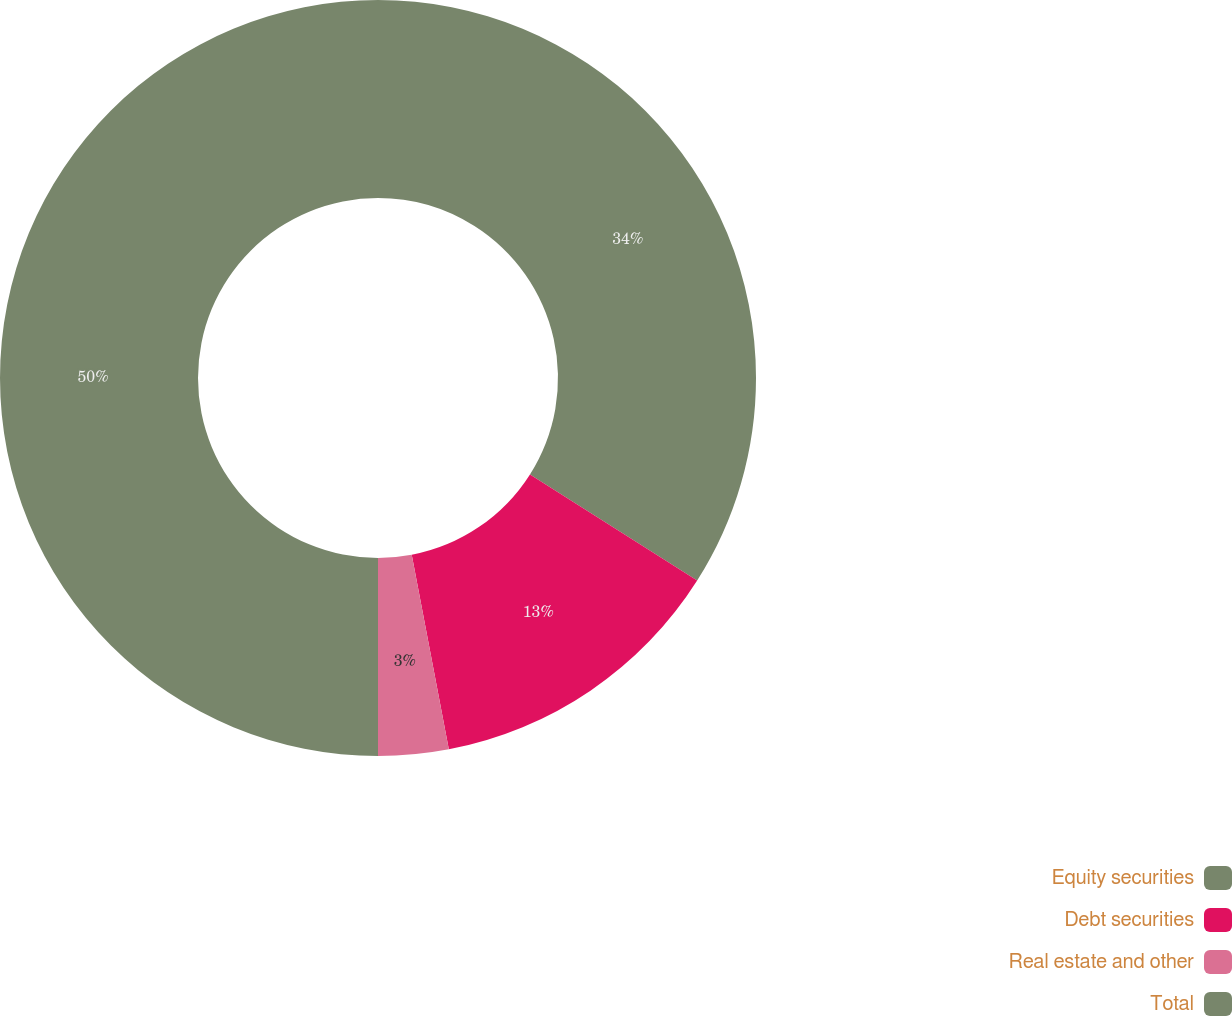Convert chart to OTSL. <chart><loc_0><loc_0><loc_500><loc_500><pie_chart><fcel>Equity securities<fcel>Debt securities<fcel>Real estate and other<fcel>Total<nl><fcel>34.0%<fcel>13.0%<fcel>3.0%<fcel>50.0%<nl></chart> 